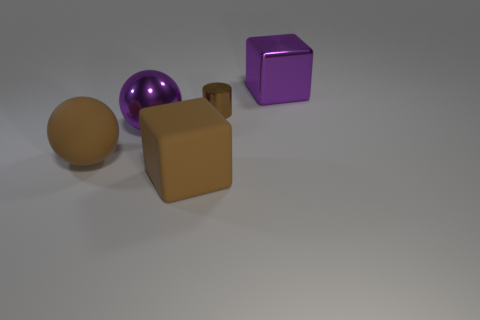Are there fewer purple metallic cubes in front of the cylinder than matte objects?
Offer a very short reply. Yes. How many other objects are the same shape as the tiny thing?
Ensure brevity in your answer.  0. How many objects are big brown things that are on the left side of the tiny brown cylinder or big purple things behind the brown metallic cylinder?
Your answer should be very brief. 3. What size is the brown object that is both on the right side of the metal ball and behind the matte block?
Keep it short and to the point. Small. There is a brown ball that is on the left side of the large purple metallic object to the left of the purple metal cube behind the tiny metallic object; how big is it?
Give a very brief answer. Large. There is a matte sphere that is the same color as the tiny object; what size is it?
Make the answer very short. Large. What number of objects are either purple metal objects or brown objects?
Make the answer very short. 5. There is a brown object that is on the right side of the brown rubber sphere and to the left of the small brown cylinder; what is its shape?
Give a very brief answer. Cube. There is a tiny object; are there any purple things to the left of it?
Offer a terse response. Yes. There is a tiny thing that is the same color as the rubber block; what is its material?
Offer a very short reply. Metal. 